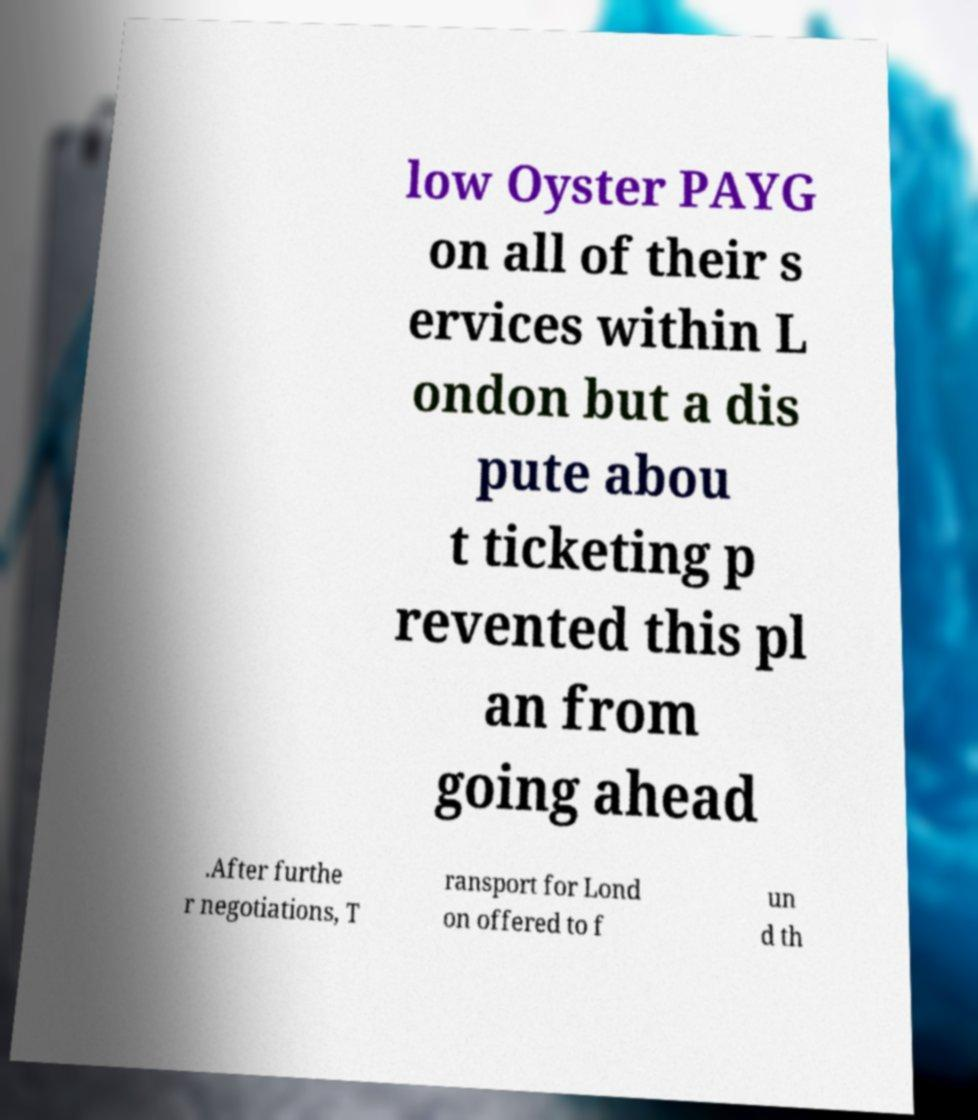Please read and relay the text visible in this image. What does it say? low Oyster PAYG on all of their s ervices within L ondon but a dis pute abou t ticketing p revented this pl an from going ahead .After furthe r negotiations, T ransport for Lond on offered to f un d th 